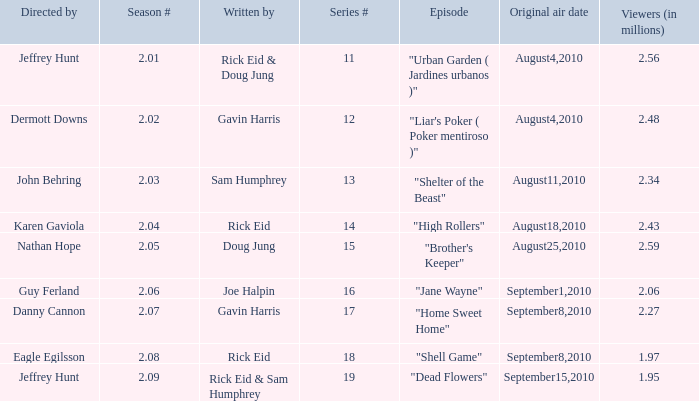What is the series minimum if the season number is 2.08? 18.0. 